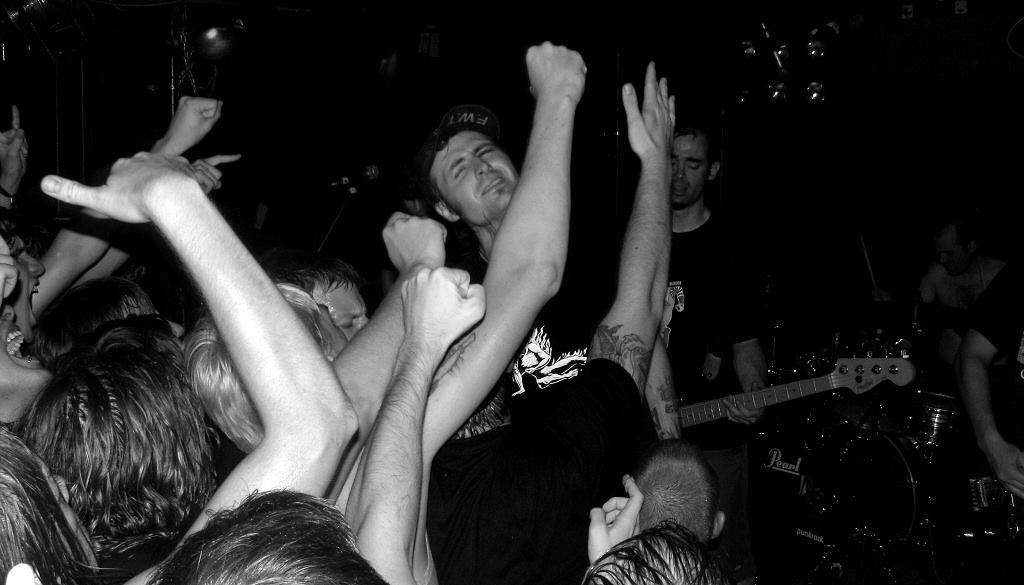What are the people in the image doing? The people in the image are dancing. Are there any musicians in the image? Yes, there is a person playing guitar and a person playing drums in the image. What type of skate is being used by the person playing drums in the image? There is no skate present in the image; the person playing drums is using drumsticks. 